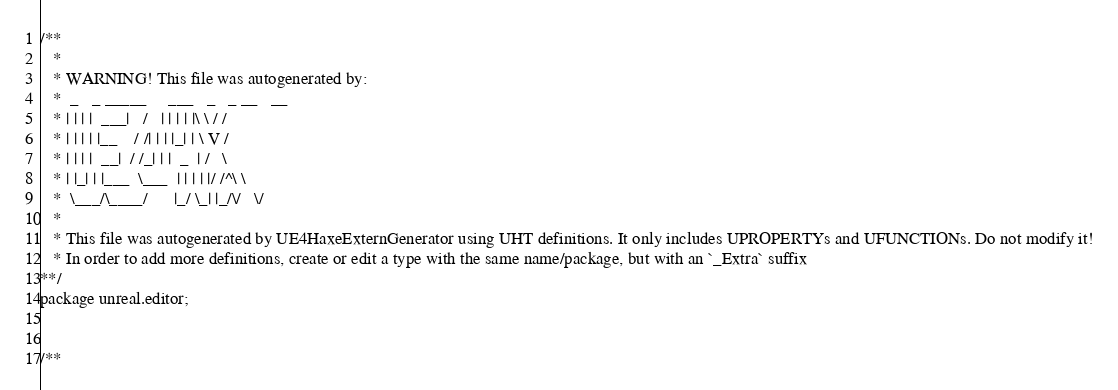<code> <loc_0><loc_0><loc_500><loc_500><_Haxe_>/**
   * 
   * WARNING! This file was autogenerated by: 
   *  _   _ _____     ___   _   _ __   __ 
   * | | | |  ___|   /   | | | | |\ \ / / 
   * | | | | |__    / /| | | |_| | \ V /  
   * | | | |  __|  / /_| | |  _  | /   \  
   * | |_| | |___  \___  | | | | |/ /^\ \ 
   *  \___/\____/      |_/ \_| |_/\/   \/ 
   * 
   * This file was autogenerated by UE4HaxeExternGenerator using UHT definitions. It only includes UPROPERTYs and UFUNCTIONs. Do not modify it!
   * In order to add more definitions, create or edit a type with the same name/package, but with an `_Extra` suffix
**/
package unreal.editor;


/**</code> 